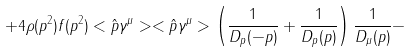Convert formula to latex. <formula><loc_0><loc_0><loc_500><loc_500>+ 4 \rho ( p ^ { 2 } ) f ( p ^ { 2 } ) < \hat { p } \gamma ^ { \mu } > < \hat { p } \gamma ^ { \mu } > \left ( \frac { 1 } { D _ { p } ( - p ) } + \frac { 1 } { D _ { p } ( p ) } \right ) \frac { 1 } { D _ { \mu } ( p ) } -</formula> 